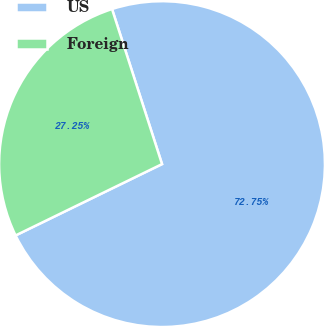<chart> <loc_0><loc_0><loc_500><loc_500><pie_chart><fcel>US<fcel>Foreign<nl><fcel>72.75%<fcel>27.25%<nl></chart> 